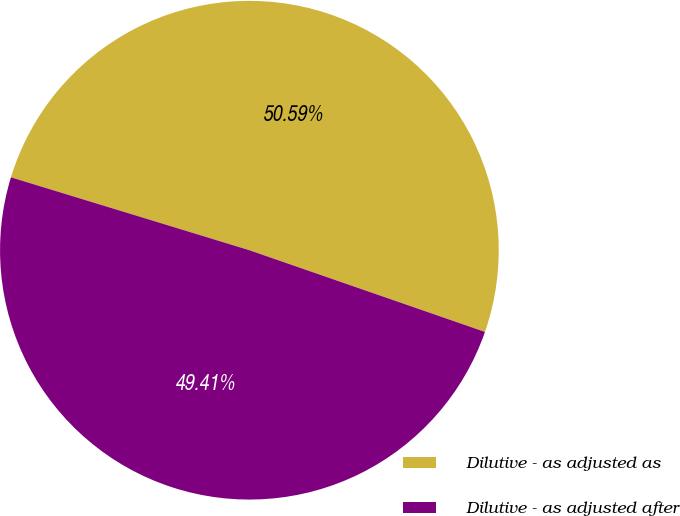Convert chart. <chart><loc_0><loc_0><loc_500><loc_500><pie_chart><fcel>Dilutive - as adjusted as<fcel>Dilutive - as adjusted after<nl><fcel>50.59%<fcel>49.41%<nl></chart> 